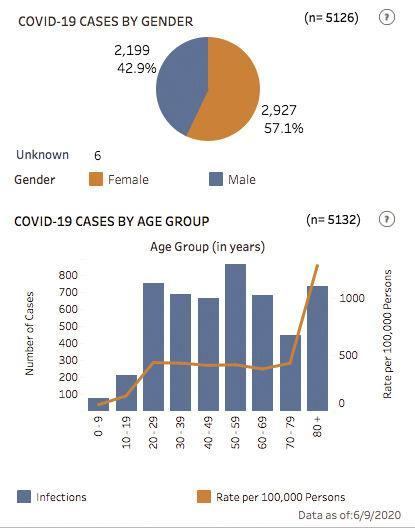Which age group has had the second least number of cases?
Answer the question with a short phrase. 10-19 How many more Covid-19 cases are reported among Females than among males? 14.2% Which age group has had the second most number of cases? 20-29 Which age group has the least number of infection rate per 100,000 persons? 0-9 Which age group has the highest number of infection rate per 100,000 persons? 80+ Which group reports more number of cases if looked at on a gender basis? Female Which age group has had the most number of cases? 50-59 Which age group has the second least number of infection rate per 100,000 persons? 10-19 